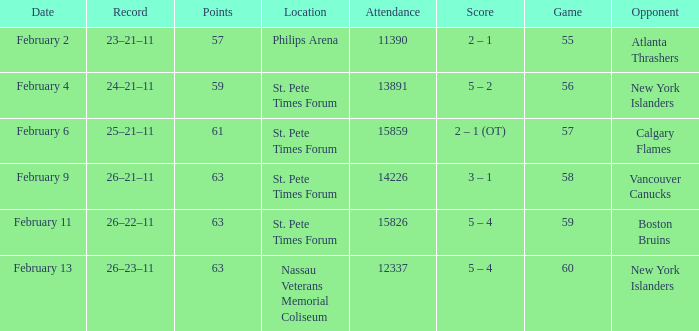What scores happened on February 9? 3 – 1. 